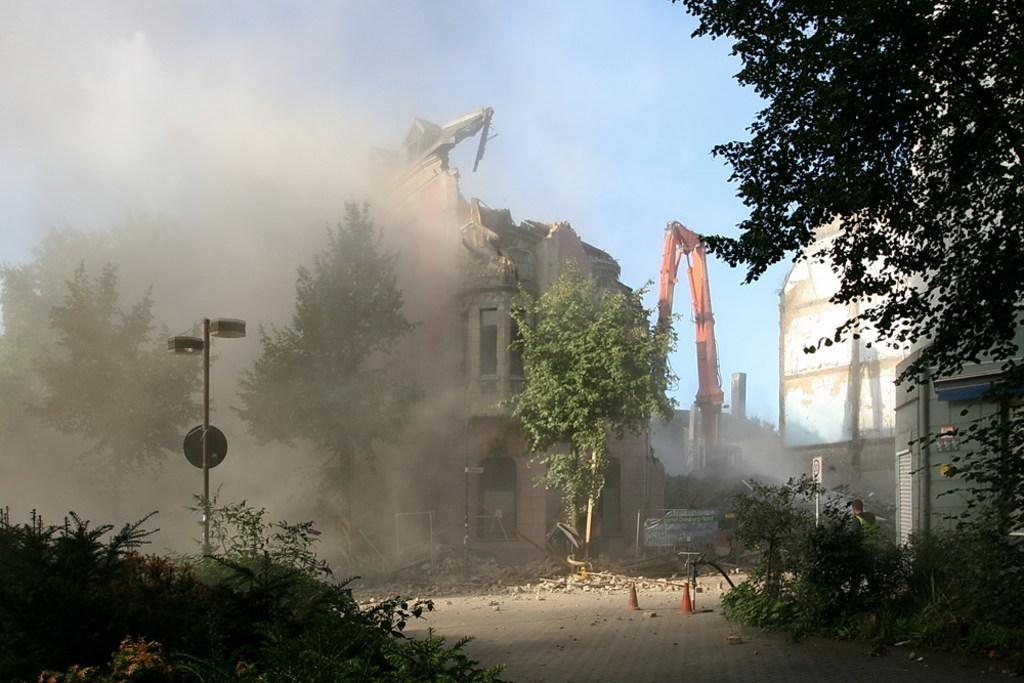How would you summarize this image in a sentence or two? In this image we can see buildings under excavation. There is a crane and we can see trees. There are boards. At the bottom we can see traffic cones. In the background there is sky. 